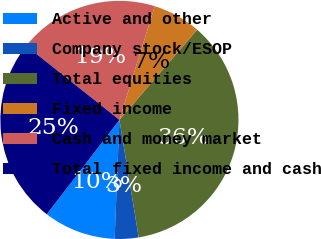Convert chart. <chart><loc_0><loc_0><loc_500><loc_500><pie_chart><fcel>Active and other<fcel>Company stock/ESOP<fcel>Total equities<fcel>Fixed income<fcel>Cash and money market<fcel>Total fixed income and cash<nl><fcel>9.81%<fcel>3.23%<fcel>36.09%<fcel>6.52%<fcel>19.11%<fcel>25.24%<nl></chart> 